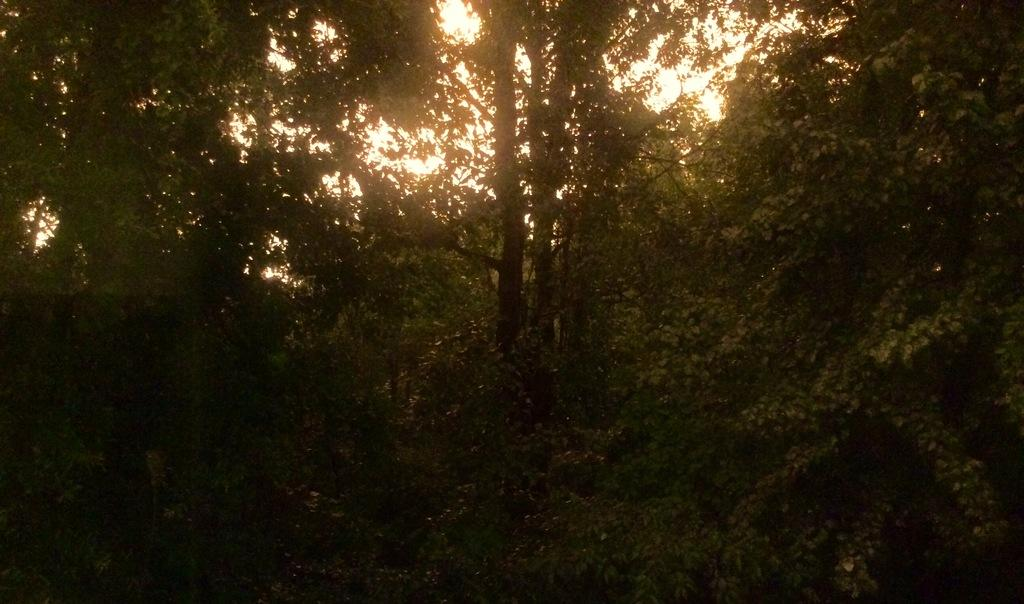What type of vegetation can be seen in the image? There are trees in the image. What is visible in the background of the image? The sky is visible in the background of the image. What is the current temperature of the mother in the image? There is no mother present in the image, and therefore no temperature can be determined. 